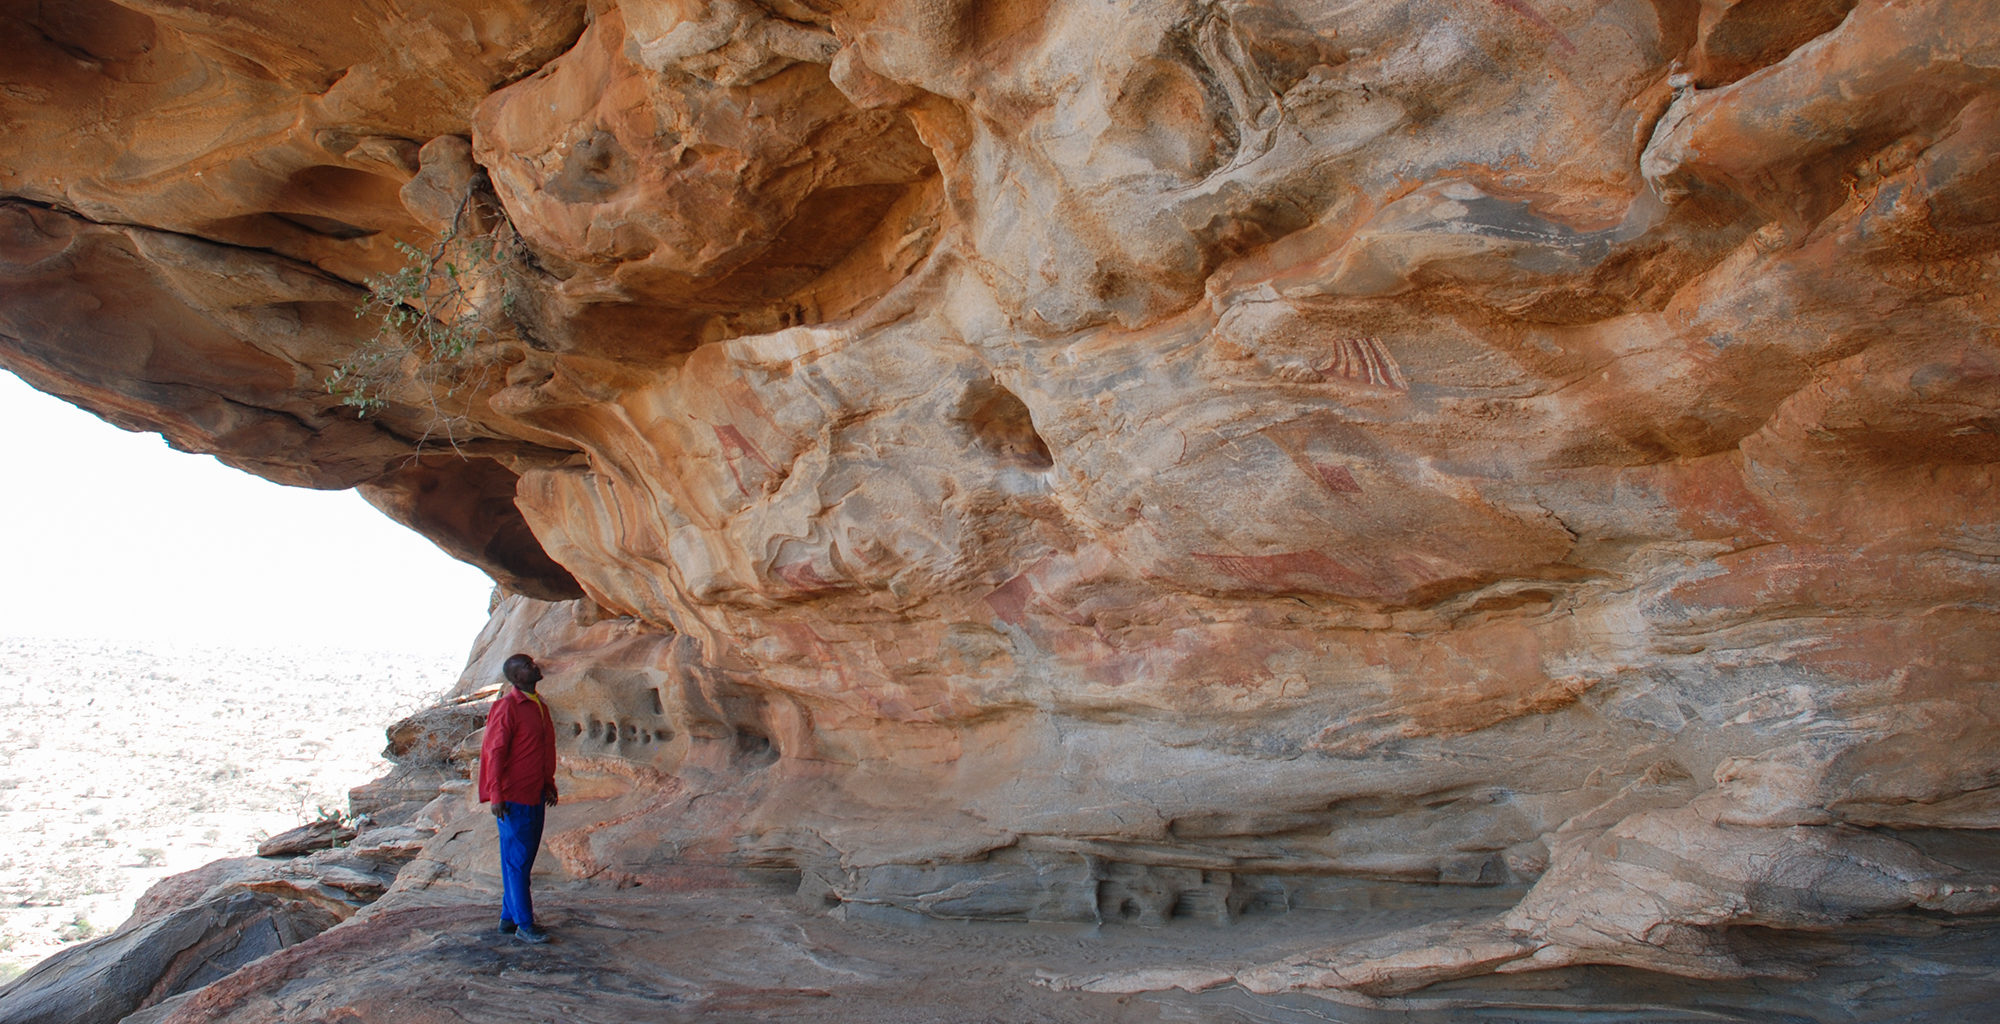Imagine a conversation between two animals that might have been painted on these rocks. What might they be discussing? In a lively exchange, a painted antelope and lion converse on the cave walls, reminiscing about their lives in the ancient savannah. The antelope speaks of the thrill of the chase and the beauty of the open plains, while the lion shares tales of pride and the hunt. They talk about the humans who painted them, the strange rituals they observed, and how those humans seemed to capture the essence of their beings with mere pigment and stone. They ponder what future generations will think of their depictions and whether they’ll be remembered as symbols of a majestic, untamed world. 